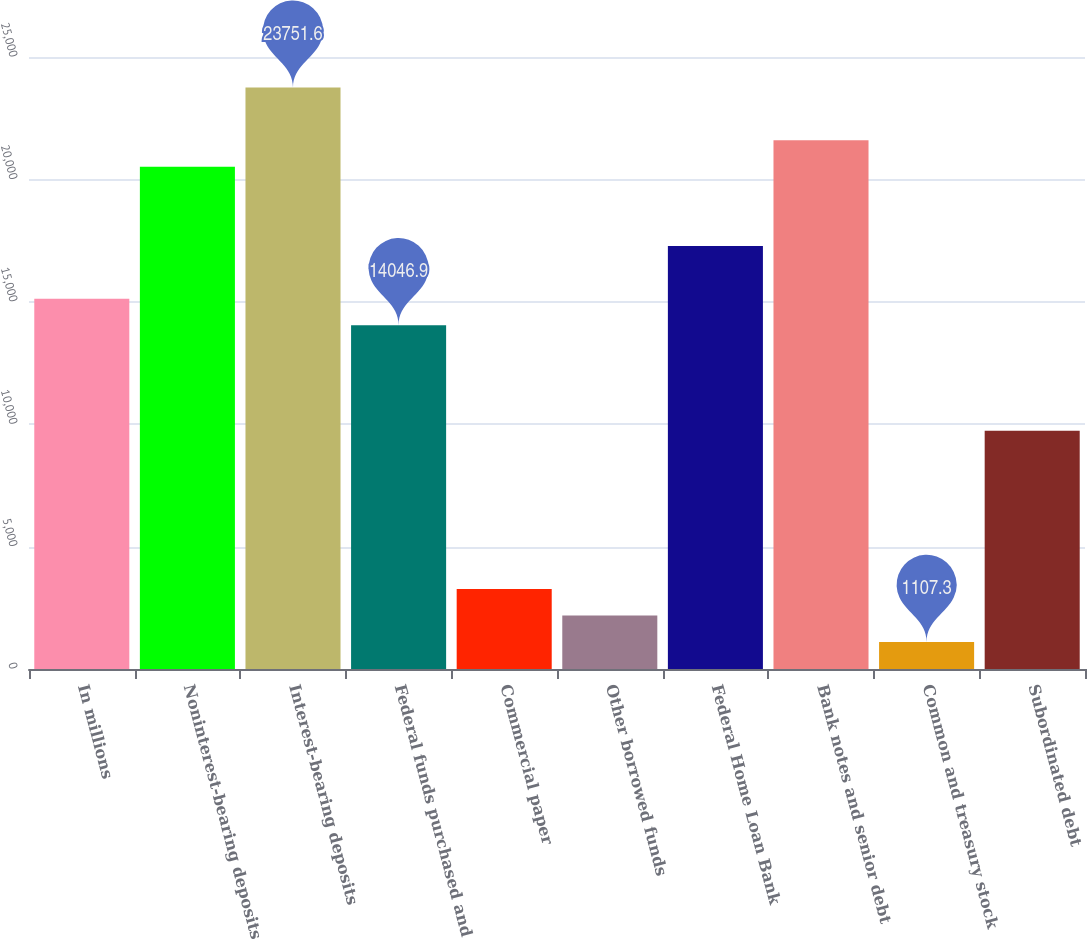<chart> <loc_0><loc_0><loc_500><loc_500><bar_chart><fcel>In millions<fcel>Noninterest-bearing deposits<fcel>Interest-bearing deposits<fcel>Federal funds purchased and<fcel>Commercial paper<fcel>Other borrowed funds<fcel>Federal Home Loan Bank<fcel>Bank notes and senior debt<fcel>Common and treasury stock<fcel>Subordinated debt<nl><fcel>15125.2<fcel>20516.7<fcel>23751.6<fcel>14046.9<fcel>3263.9<fcel>2185.6<fcel>17281.8<fcel>21595<fcel>1107.3<fcel>9733.7<nl></chart> 